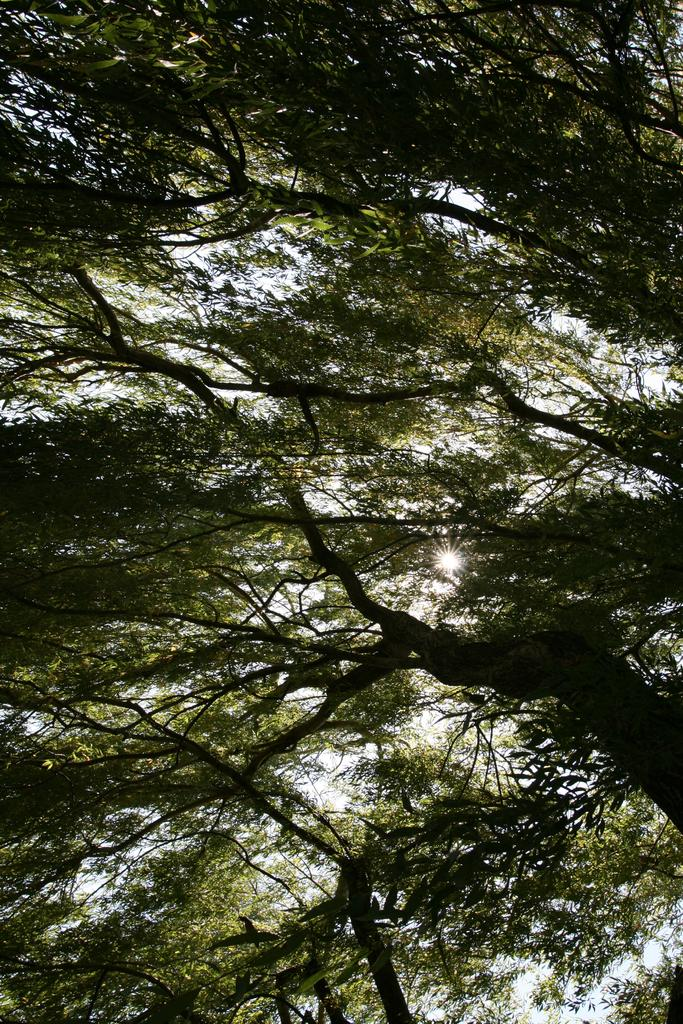What type of trees can be seen in the image? There are tall trees with green leaves in the image. How many tree trunks are visible in the image? There are multiple tree trunks visible in the image. What is visible at the top of the image? The sky is visible at the top of the image. What is the sugar content of the leaves on the trees in the image? There is no information about the sugar content of the leaves in the image, as the focus is on the trees' appearance and the sky visible at the top. 